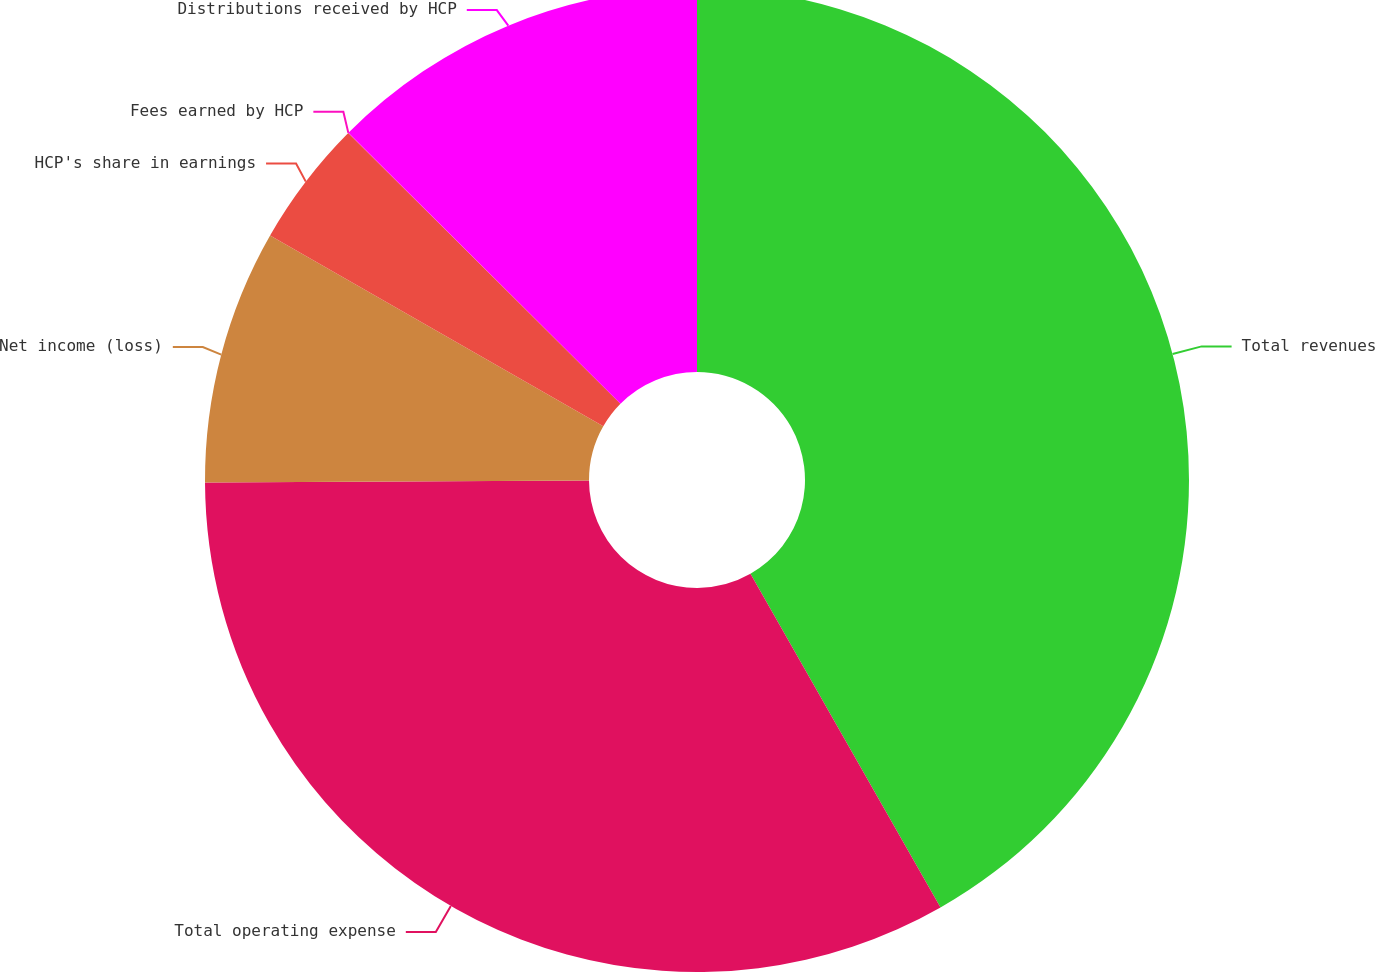Convert chart. <chart><loc_0><loc_0><loc_500><loc_500><pie_chart><fcel>Total revenues<fcel>Total operating expense<fcel>Net income (loss)<fcel>HCP's share in earnings<fcel>Fees earned by HCP<fcel>Distributions received by HCP<nl><fcel>41.76%<fcel>33.16%<fcel>8.36%<fcel>4.18%<fcel>0.01%<fcel>12.53%<nl></chart> 